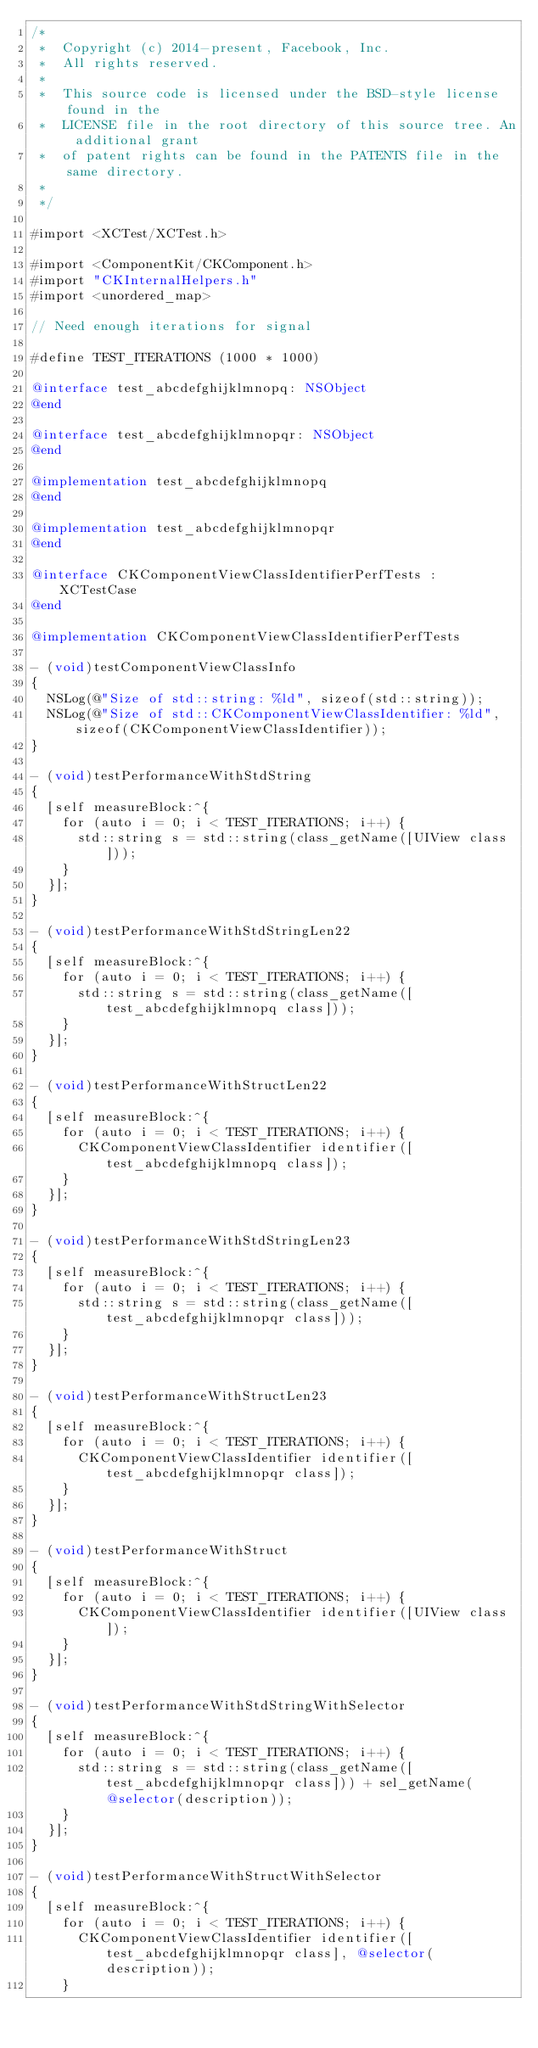<code> <loc_0><loc_0><loc_500><loc_500><_ObjectiveC_>/*
 *  Copyright (c) 2014-present, Facebook, Inc.
 *  All rights reserved.
 *
 *  This source code is licensed under the BSD-style license found in the
 *  LICENSE file in the root directory of this source tree. An additional grant
 *  of patent rights can be found in the PATENTS file in the same directory.
 *
 */

#import <XCTest/XCTest.h>

#import <ComponentKit/CKComponent.h>
#import "CKInternalHelpers.h"
#import <unordered_map>

// Need enough iterations for signal

#define TEST_ITERATIONS (1000 * 1000)

@interface test_abcdefghijklmnopq: NSObject
@end

@interface test_abcdefghijklmnopqr: NSObject
@end

@implementation test_abcdefghijklmnopq
@end

@implementation test_abcdefghijklmnopqr
@end

@interface CKComponentViewClassIdentifierPerfTests : XCTestCase
@end

@implementation CKComponentViewClassIdentifierPerfTests

- (void)testComponentViewClassInfo
{
  NSLog(@"Size of std::string: %ld", sizeof(std::string));
  NSLog(@"Size of std::CKComponentViewClassIdentifier: %ld", sizeof(CKComponentViewClassIdentifier));
}

- (void)testPerformanceWithStdString
{
  [self measureBlock:^{
    for (auto i = 0; i < TEST_ITERATIONS; i++) {
      std::string s = std::string(class_getName([UIView class]));
    }
  }];
}

- (void)testPerformanceWithStdStringLen22
{
  [self measureBlock:^{
    for (auto i = 0; i < TEST_ITERATIONS; i++) {
      std::string s = std::string(class_getName([test_abcdefghijklmnopq class]));
    }
  }];
}

- (void)testPerformanceWithStructLen22
{
  [self measureBlock:^{
    for (auto i = 0; i < TEST_ITERATIONS; i++) {
      CKComponentViewClassIdentifier identifier([test_abcdefghijklmnopq class]);
    }
  }];
}

- (void)testPerformanceWithStdStringLen23
{
  [self measureBlock:^{
    for (auto i = 0; i < TEST_ITERATIONS; i++) {
      std::string s = std::string(class_getName([test_abcdefghijklmnopqr class]));
    }
  }];
}

- (void)testPerformanceWithStructLen23
{
  [self measureBlock:^{
    for (auto i = 0; i < TEST_ITERATIONS; i++) {
      CKComponentViewClassIdentifier identifier([test_abcdefghijklmnopqr class]);
    }
  }];
}

- (void)testPerformanceWithStruct
{
  [self measureBlock:^{
    for (auto i = 0; i < TEST_ITERATIONS; i++) {
      CKComponentViewClassIdentifier identifier([UIView class]);
    }
  }];
}

- (void)testPerformanceWithStdStringWithSelector
{
  [self measureBlock:^{
    for (auto i = 0; i < TEST_ITERATIONS; i++) {
      std::string s = std::string(class_getName([test_abcdefghijklmnopqr class])) + sel_getName(@selector(description));
    }
  }];
}

- (void)testPerformanceWithStructWithSelector
{
  [self measureBlock:^{
    for (auto i = 0; i < TEST_ITERATIONS; i++) {
      CKComponentViewClassIdentifier identifier([test_abcdefghijklmnopqr class], @selector(description));
    }</code> 